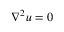<formula> <loc_0><loc_0><loc_500><loc_500>\nabla ^ { 2 } u = 0</formula> 